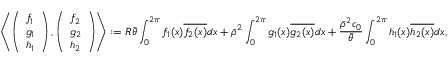Convert formula to latex. <formula><loc_0><loc_0><loc_500><loc_500>\left \langle \left ( \begin{array} { l } { f _ { 1 } } \\ { g _ { 1 } } \\ { h _ { 1 } } \end{array} \right ) , \left ( \begin{array} { l } { f _ { 2 } } \\ { g _ { 2 } } \\ { h _ { 2 } } \end{array} \right ) \right \rangle \colon = R \bar { \theta } \int _ { 0 } ^ { 2 \pi } f _ { 1 } ( x ) \overline { { f _ { 2 } ( x ) } } d x + \bar { \rho } ^ { 2 } \int _ { 0 } ^ { 2 \pi } g _ { 1 } ( x ) \overline { { g _ { 2 } ( x ) } } d x + \frac { \bar { \rho } ^ { 2 } c _ { 0 } } { \bar { \theta } } \int _ { 0 } ^ { 2 \pi } h _ { 1 } ( x ) \overline { { h _ { 2 } ( x ) } } d x ,</formula> 